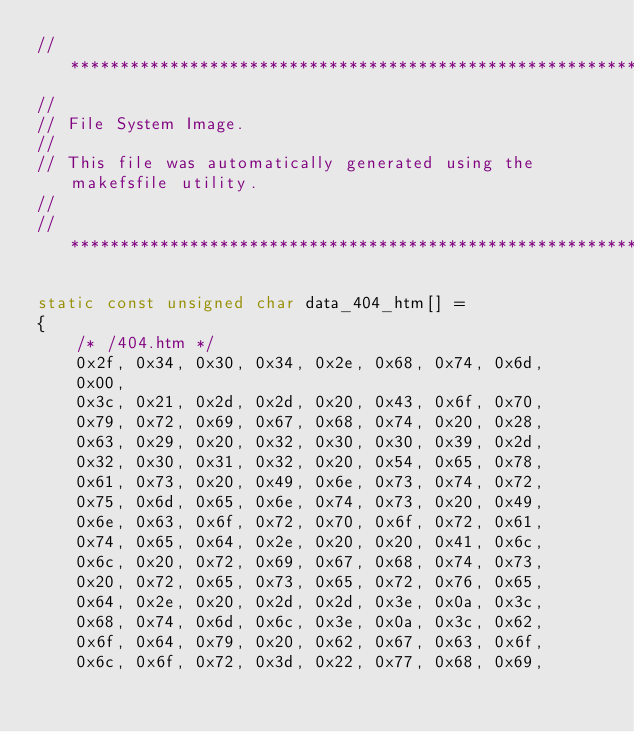Convert code to text. <code><loc_0><loc_0><loc_500><loc_500><_C_>//***************************************************************************
//
// File System Image.
//
// This file was automatically generated using the makefsfile utility.
//
//***************************************************************************

static const unsigned char data_404_htm[] =
{
	/* /404.htm */
    0x2f, 0x34, 0x30, 0x34, 0x2e, 0x68, 0x74, 0x6d,
    0x00,
    0x3c, 0x21, 0x2d, 0x2d, 0x20, 0x43, 0x6f, 0x70,
    0x79, 0x72, 0x69, 0x67, 0x68, 0x74, 0x20, 0x28,
    0x63, 0x29, 0x20, 0x32, 0x30, 0x30, 0x39, 0x2d,
    0x32, 0x30, 0x31, 0x32, 0x20, 0x54, 0x65, 0x78,
    0x61, 0x73, 0x20, 0x49, 0x6e, 0x73, 0x74, 0x72,
    0x75, 0x6d, 0x65, 0x6e, 0x74, 0x73, 0x20, 0x49,
    0x6e, 0x63, 0x6f, 0x72, 0x70, 0x6f, 0x72, 0x61,
    0x74, 0x65, 0x64, 0x2e, 0x20, 0x20, 0x41, 0x6c,
    0x6c, 0x20, 0x72, 0x69, 0x67, 0x68, 0x74, 0x73,
    0x20, 0x72, 0x65, 0x73, 0x65, 0x72, 0x76, 0x65,
    0x64, 0x2e, 0x20, 0x2d, 0x2d, 0x3e, 0x0a, 0x3c,
    0x68, 0x74, 0x6d, 0x6c, 0x3e, 0x0a, 0x3c, 0x62,
    0x6f, 0x64, 0x79, 0x20, 0x62, 0x67, 0x63, 0x6f,
    0x6c, 0x6f, 0x72, 0x3d, 0x22, 0x77, 0x68, 0x69,</code> 